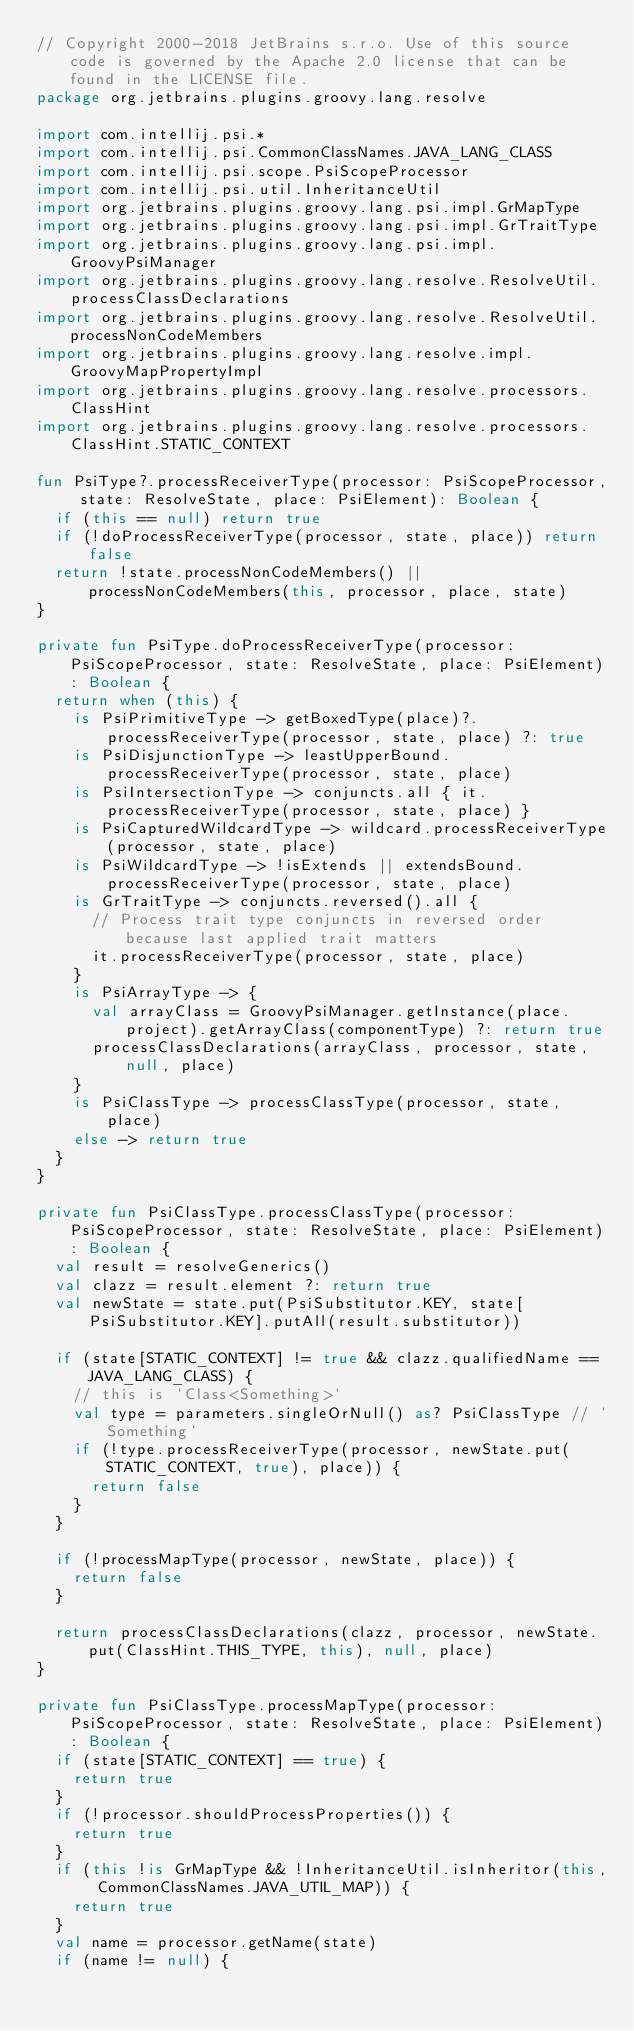Convert code to text. <code><loc_0><loc_0><loc_500><loc_500><_Kotlin_>// Copyright 2000-2018 JetBrains s.r.o. Use of this source code is governed by the Apache 2.0 license that can be found in the LICENSE file.
package org.jetbrains.plugins.groovy.lang.resolve

import com.intellij.psi.*
import com.intellij.psi.CommonClassNames.JAVA_LANG_CLASS
import com.intellij.psi.scope.PsiScopeProcessor
import com.intellij.psi.util.InheritanceUtil
import org.jetbrains.plugins.groovy.lang.psi.impl.GrMapType
import org.jetbrains.plugins.groovy.lang.psi.impl.GrTraitType
import org.jetbrains.plugins.groovy.lang.psi.impl.GroovyPsiManager
import org.jetbrains.plugins.groovy.lang.resolve.ResolveUtil.processClassDeclarations
import org.jetbrains.plugins.groovy.lang.resolve.ResolveUtil.processNonCodeMembers
import org.jetbrains.plugins.groovy.lang.resolve.impl.GroovyMapPropertyImpl
import org.jetbrains.plugins.groovy.lang.resolve.processors.ClassHint
import org.jetbrains.plugins.groovy.lang.resolve.processors.ClassHint.STATIC_CONTEXT

fun PsiType?.processReceiverType(processor: PsiScopeProcessor, state: ResolveState, place: PsiElement): Boolean {
  if (this == null) return true
  if (!doProcessReceiverType(processor, state, place)) return false
  return !state.processNonCodeMembers() || processNonCodeMembers(this, processor, place, state)
}

private fun PsiType.doProcessReceiverType(processor: PsiScopeProcessor, state: ResolveState, place: PsiElement): Boolean {
  return when (this) {
    is PsiPrimitiveType -> getBoxedType(place)?.processReceiverType(processor, state, place) ?: true
    is PsiDisjunctionType -> leastUpperBound.processReceiverType(processor, state, place)
    is PsiIntersectionType -> conjuncts.all { it.processReceiverType(processor, state, place) }
    is PsiCapturedWildcardType -> wildcard.processReceiverType(processor, state, place)
    is PsiWildcardType -> !isExtends || extendsBound.processReceiverType(processor, state, place)
    is GrTraitType -> conjuncts.reversed().all {
      // Process trait type conjuncts in reversed order because last applied trait matters
      it.processReceiverType(processor, state, place)
    }
    is PsiArrayType -> {
      val arrayClass = GroovyPsiManager.getInstance(place.project).getArrayClass(componentType) ?: return true
      processClassDeclarations(arrayClass, processor, state, null, place)
    }
    is PsiClassType -> processClassType(processor, state, place)
    else -> return true
  }
}

private fun PsiClassType.processClassType(processor: PsiScopeProcessor, state: ResolveState, place: PsiElement): Boolean {
  val result = resolveGenerics()
  val clazz = result.element ?: return true
  val newState = state.put(PsiSubstitutor.KEY, state[PsiSubstitutor.KEY].putAll(result.substitutor))

  if (state[STATIC_CONTEXT] != true && clazz.qualifiedName == JAVA_LANG_CLASS) {
    // this is `Class<Something>`
    val type = parameters.singleOrNull() as? PsiClassType // `Something`
    if (!type.processReceiverType(processor, newState.put(STATIC_CONTEXT, true), place)) {
      return false
    }
  }

  if (!processMapType(processor, newState, place)) {
    return false
  }

  return processClassDeclarations(clazz, processor, newState.put(ClassHint.THIS_TYPE, this), null, place)
}

private fun PsiClassType.processMapType(processor: PsiScopeProcessor, state: ResolveState, place: PsiElement): Boolean {
  if (state[STATIC_CONTEXT] == true) {
    return true
  }
  if (!processor.shouldProcessProperties()) {
    return true
  }
  if (this !is GrMapType && !InheritanceUtil.isInheritor(this, CommonClassNames.JAVA_UTIL_MAP)) {
    return true
  }
  val name = processor.getName(state)
  if (name != null) {</code> 